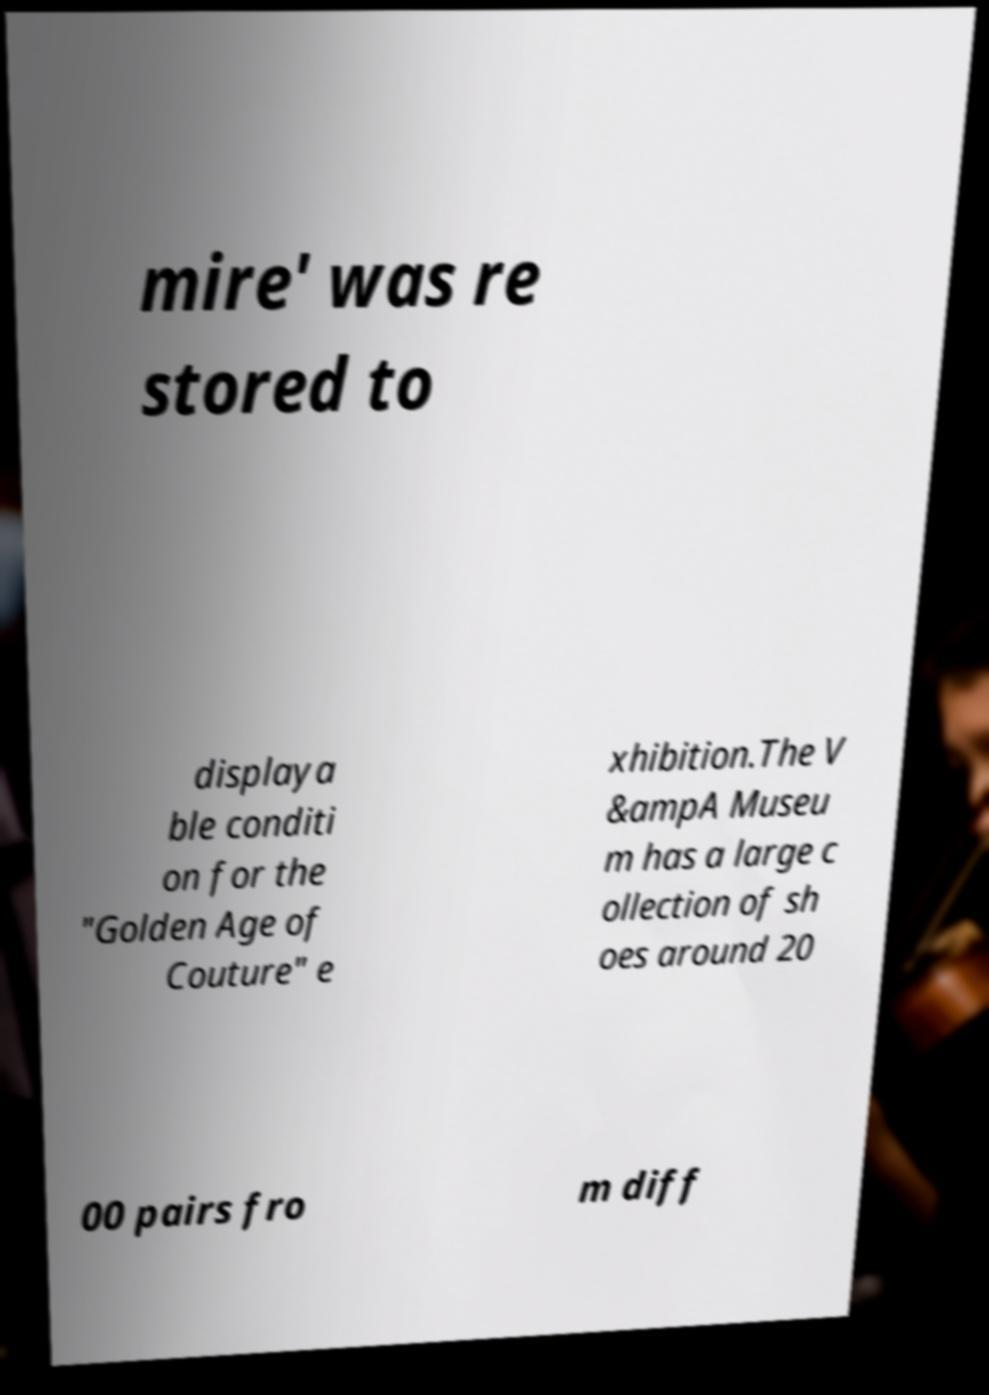Could you assist in decoding the text presented in this image and type it out clearly? mire' was re stored to displaya ble conditi on for the "Golden Age of Couture" e xhibition.The V &ampA Museu m has a large c ollection of sh oes around 20 00 pairs fro m diff 